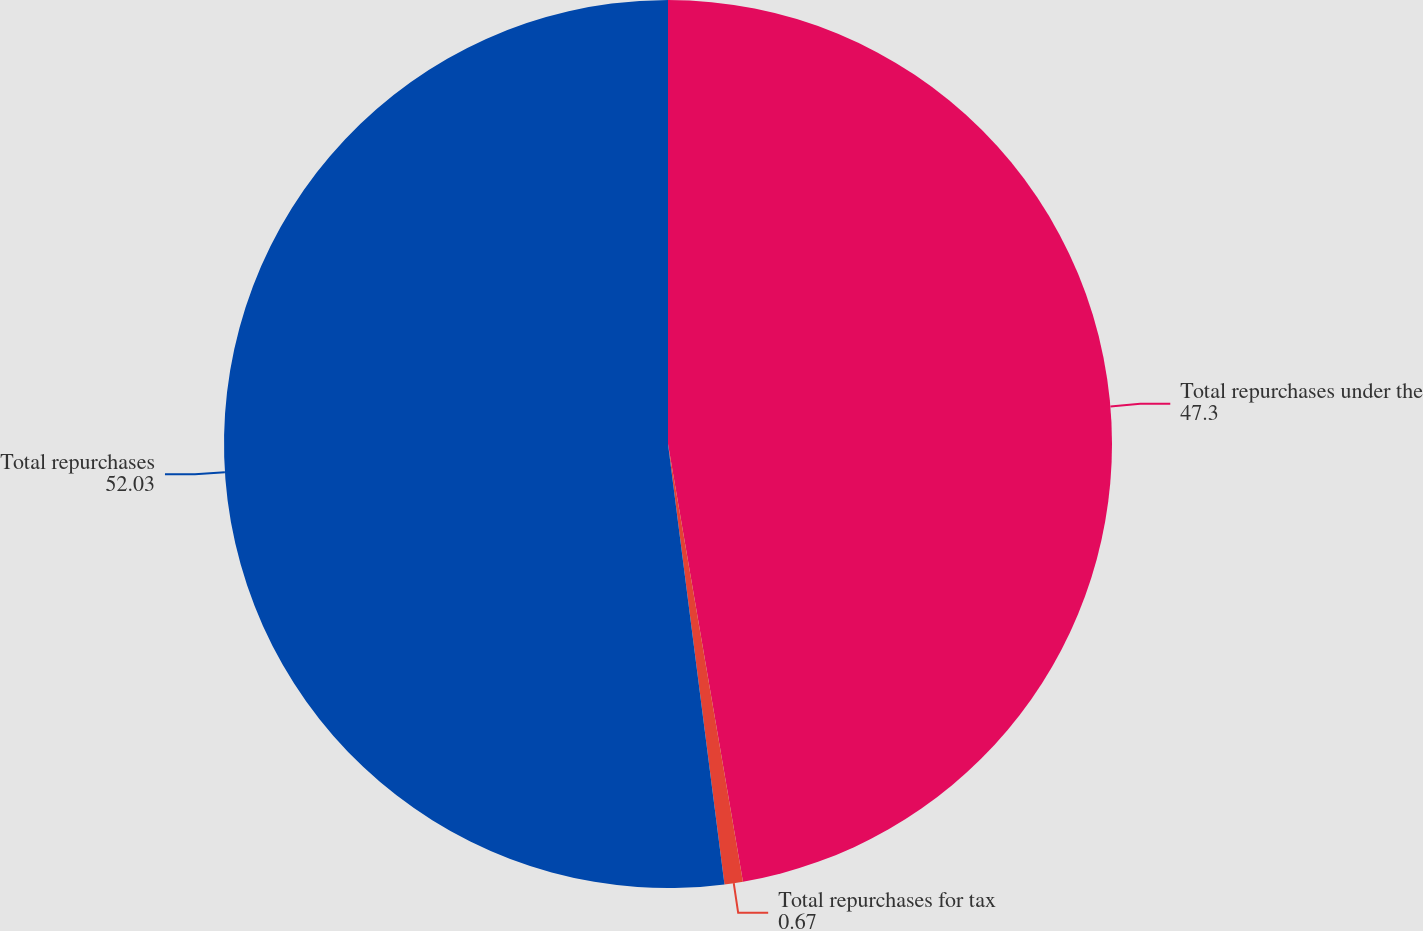Convert chart to OTSL. <chart><loc_0><loc_0><loc_500><loc_500><pie_chart><fcel>Total repurchases under the<fcel>Total repurchases for tax<fcel>Total repurchases<nl><fcel>47.3%<fcel>0.67%<fcel>52.03%<nl></chart> 